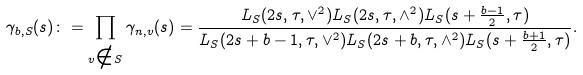Convert formula to latex. <formula><loc_0><loc_0><loc_500><loc_500>\gamma _ { b , S } ( s ) \colon = \prod _ { v \notin S } \gamma _ { n , v } ( s ) = \frac { L _ { S } ( 2 s , \tau , \vee ^ { 2 } ) L _ { S } ( 2 s , \tau , \wedge ^ { 2 } ) L _ { S } ( s + \frac { b - 1 } { 2 } , \tau ) } { L _ { S } ( 2 s + b - 1 , \tau , \vee ^ { 2 } ) L _ { S } ( 2 s + b , \tau , \wedge ^ { 2 } ) L _ { S } ( s + \frac { b + 1 } { 2 } , \tau ) } .</formula> 